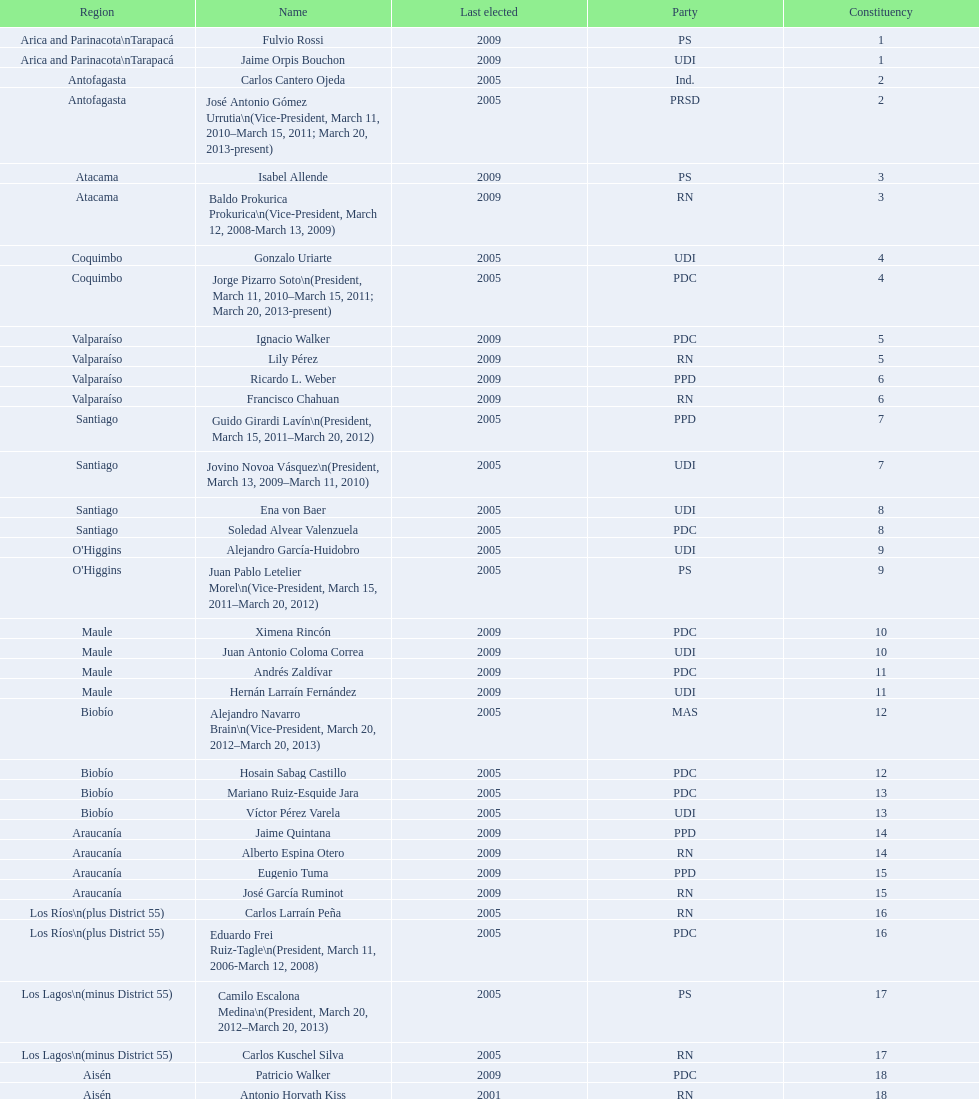Who was not last elected in either 2005 or 2009? Antonio Horvath Kiss. 